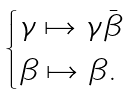<formula> <loc_0><loc_0><loc_500><loc_500>\begin{cases} \gamma \mapsto \gamma \bar { \beta } \\ \beta \mapsto \beta . \end{cases}</formula> 